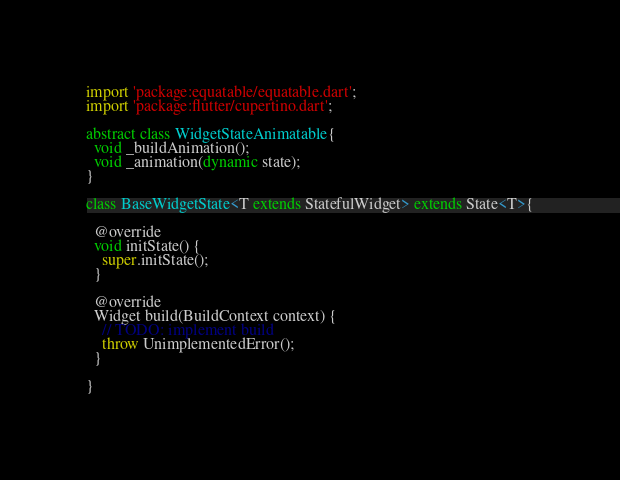<code> <loc_0><loc_0><loc_500><loc_500><_Dart_>import 'package:equatable/equatable.dart';
import 'package:flutter/cupertino.dart';

abstract class WidgetStateAnimatable{
  void _buildAnimation();
  void _animation(dynamic state);
}

class BaseWidgetState<T extends StatefulWidget> extends State<T>{

  @override
  void initState() {
    super.initState();
  }

  @override
  Widget build(BuildContext context) {
    // TODO: implement build
    throw UnimplementedError();
  }

}</code> 